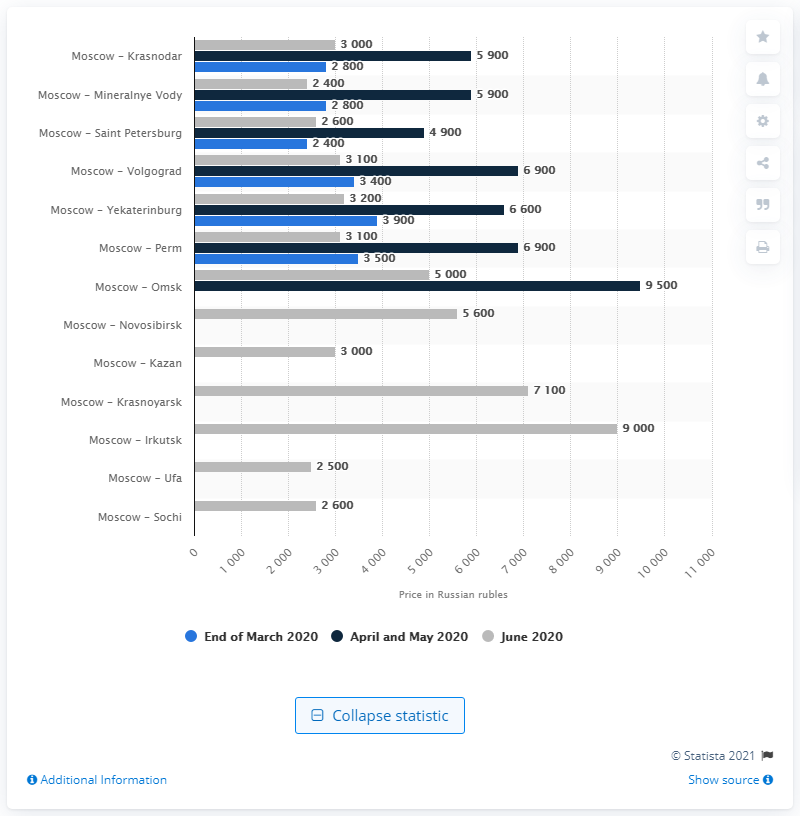List a handful of essential elements in this visual. Aeroflot - Russian airlines increased the prices of flights within the country in April and May 2020. The passenger count of Aeroflot decreased by 2,600 in February 2020 compared to the same period in 2019. The minimum price of a one-way ticket from the first to the second largest city in the country was 2600. 